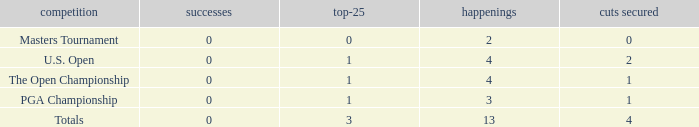How many cuts made in the tournament he played 13 times? None. 